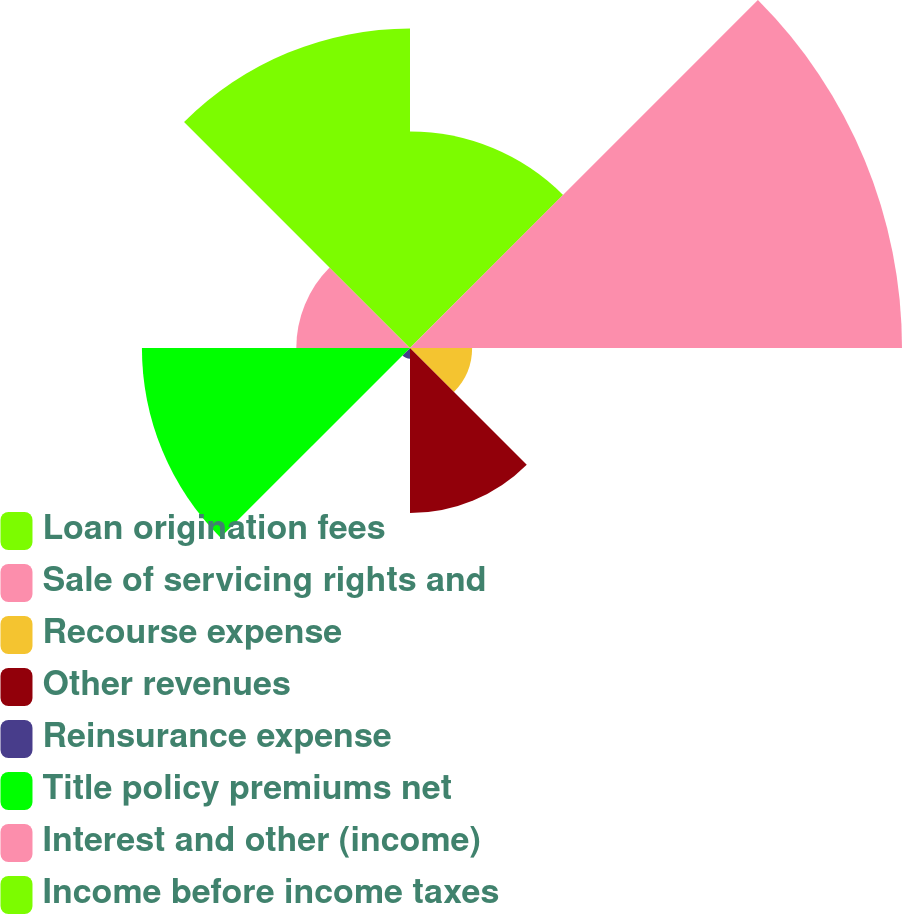Convert chart to OTSL. <chart><loc_0><loc_0><loc_500><loc_500><pie_chart><fcel>Loan origination fees<fcel>Sale of servicing rights and<fcel>Recourse expense<fcel>Other revenues<fcel>Reinsurance expense<fcel>Title policy premiums net<fcel>Interest and other (income)<fcel>Income before income taxes<nl><fcel>13.14%<fcel>29.86%<fcel>3.77%<fcel>10.02%<fcel>0.65%<fcel>16.27%<fcel>6.9%<fcel>19.39%<nl></chart> 